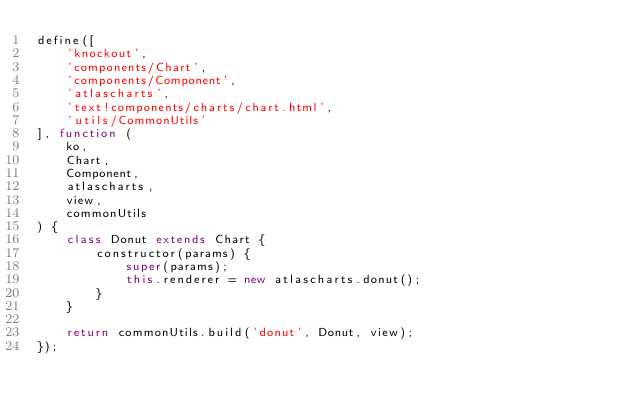Convert code to text. <code><loc_0><loc_0><loc_500><loc_500><_JavaScript_>define([
	'knockout',
	'components/Chart',
	'components/Component',
	'atlascharts',
	'text!components/charts/chart.html',
	'utils/CommonUtils'
], function (
	ko,
	Chart,
	Component,
	atlascharts,
	view,
	commonUtils
) {
	class Donut extends Chart {
		constructor(params) {
			super(params);
			this.renderer = new atlascharts.donut();
		}
	}

	return commonUtils.build('donut', Donut, view);
});
</code> 